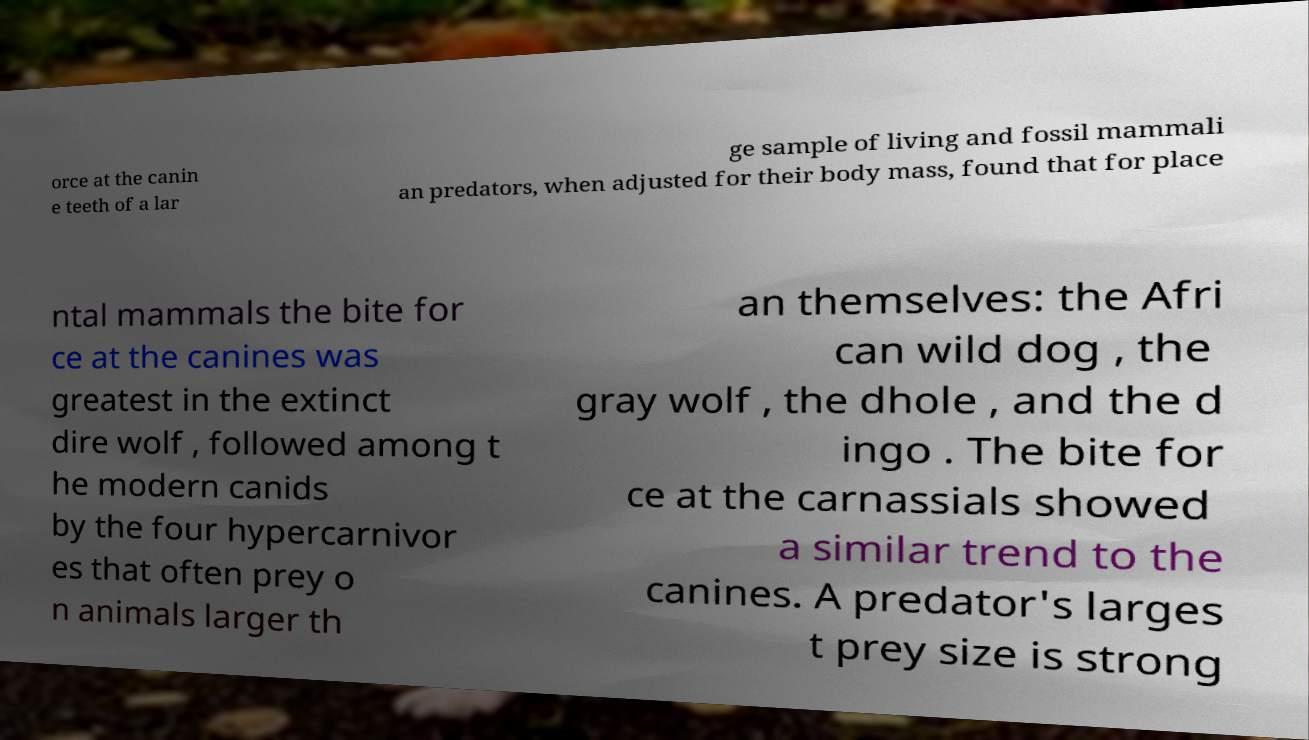Please read and relay the text visible in this image. What does it say? orce at the canin e teeth of a lar ge sample of living and fossil mammali an predators, when adjusted for their body mass, found that for place ntal mammals the bite for ce at the canines was greatest in the extinct dire wolf , followed among t he modern canids by the four hypercarnivor es that often prey o n animals larger th an themselves: the Afri can wild dog , the gray wolf , the dhole , and the d ingo . The bite for ce at the carnassials showed a similar trend to the canines. A predator's larges t prey size is strong 